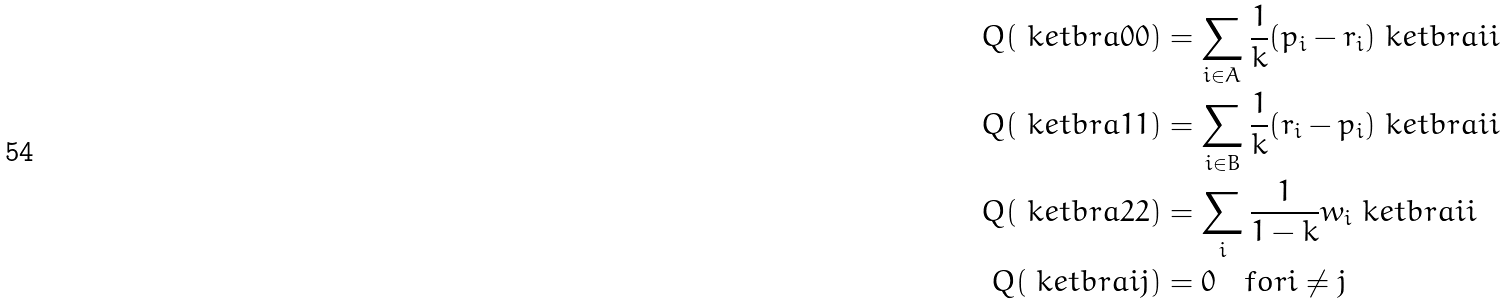<formula> <loc_0><loc_0><loc_500><loc_500>Q ( \ k e t b r a { 0 } { 0 } ) & = \sum _ { i \in A } \frac { 1 } { k } ( p _ { i } - r _ { i } ) \ k e t b r a { i } { i } \\ Q ( \ k e t b r a { 1 } { 1 } ) & = \sum _ { i \in B } \frac { 1 } { k } ( r _ { i } - p _ { i } ) \ k e t b r a { i } { i } \\ Q ( \ k e t b r a { 2 } { 2 } ) & = \sum _ { i } \frac { 1 } { 1 - k } w _ { i } \ k e t b r a { i } { i } \\ Q ( \ k e t b r a { i } { j } ) & = 0 \quad f o r i \neq j</formula> 